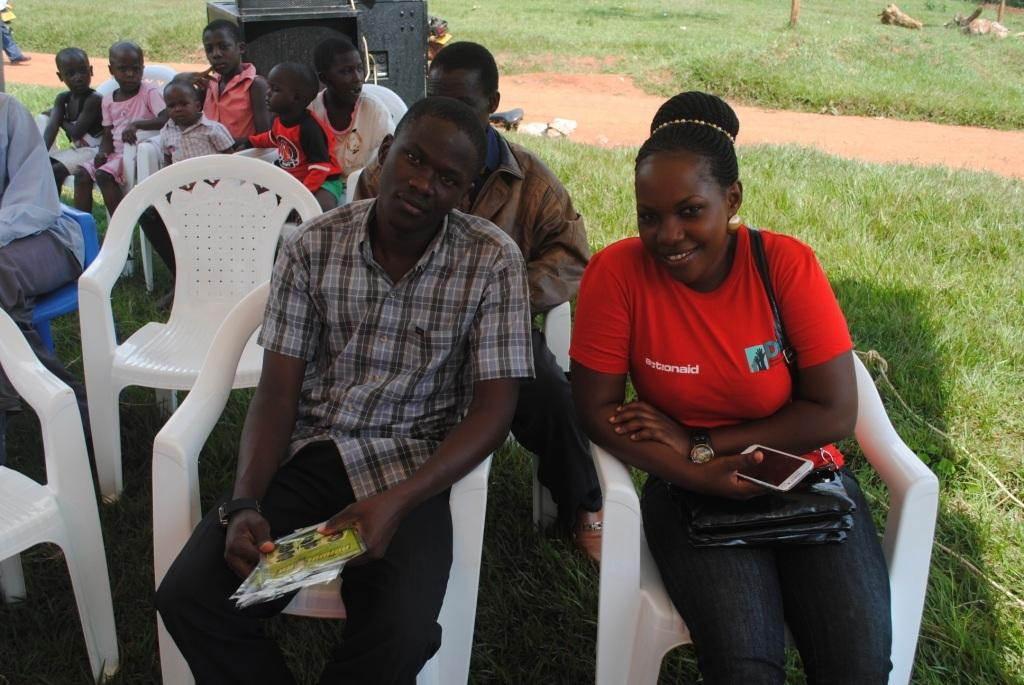Who or what is present in the image? There are people in the image. What are the people doing in the image? The people are sitting on chairs. What type of surface is the ground covered with? The ground is covered with grass. What type of soup is being served to the people in the image? There is no soup present in the image; the people are sitting on chairs with no food or drink visible. 